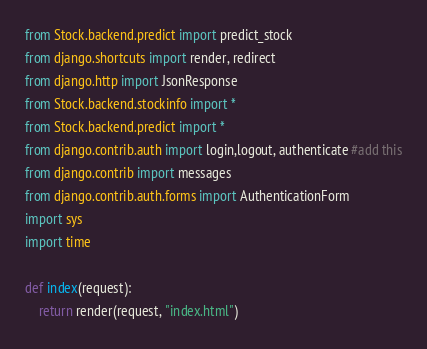Convert code to text. <code><loc_0><loc_0><loc_500><loc_500><_Python_>from Stock.backend.predict import predict_stock
from django.shortcuts import render, redirect
from django.http import JsonResponse
from Stock.backend.stockinfo import *
from Stock.backend.predict import *
from django.contrib.auth import login,logout, authenticate #add this
from django.contrib import messages
from django.contrib.auth.forms import AuthenticationForm
import sys
import time

def index(request):
    return render(request, "index.html")

</code> 